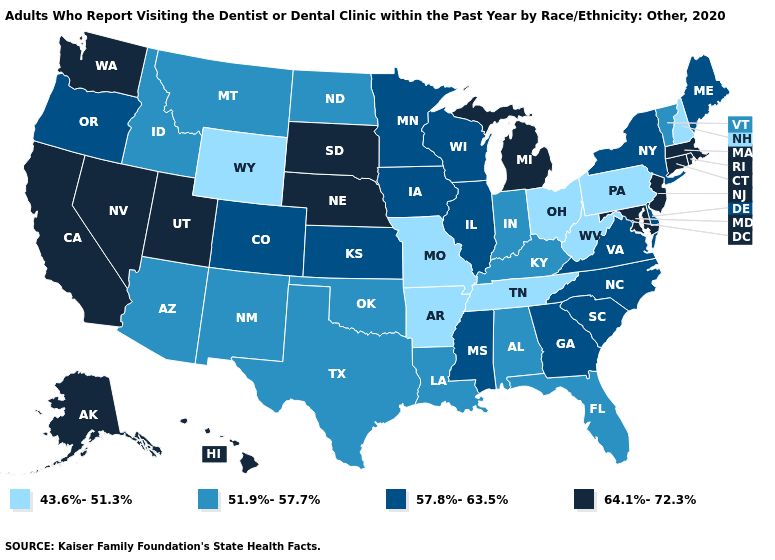Which states have the highest value in the USA?
Give a very brief answer. Alaska, California, Connecticut, Hawaii, Maryland, Massachusetts, Michigan, Nebraska, Nevada, New Jersey, Rhode Island, South Dakota, Utah, Washington. Name the states that have a value in the range 43.6%-51.3%?
Concise answer only. Arkansas, Missouri, New Hampshire, Ohio, Pennsylvania, Tennessee, West Virginia, Wyoming. Which states have the lowest value in the MidWest?
Short answer required. Missouri, Ohio. Among the states that border North Carolina , which have the highest value?
Keep it brief. Georgia, South Carolina, Virginia. Name the states that have a value in the range 64.1%-72.3%?
Give a very brief answer. Alaska, California, Connecticut, Hawaii, Maryland, Massachusetts, Michigan, Nebraska, Nevada, New Jersey, Rhode Island, South Dakota, Utah, Washington. How many symbols are there in the legend?
Answer briefly. 4. Is the legend a continuous bar?
Keep it brief. No. Among the states that border Mississippi , does Louisiana have the lowest value?
Be succinct. No. What is the highest value in the Northeast ?
Concise answer only. 64.1%-72.3%. What is the value of Texas?
Quick response, please. 51.9%-57.7%. What is the value of Colorado?
Give a very brief answer. 57.8%-63.5%. What is the lowest value in the South?
Give a very brief answer. 43.6%-51.3%. Among the states that border Maryland , does West Virginia have the highest value?
Concise answer only. No. Name the states that have a value in the range 51.9%-57.7%?
Write a very short answer. Alabama, Arizona, Florida, Idaho, Indiana, Kentucky, Louisiana, Montana, New Mexico, North Dakota, Oklahoma, Texas, Vermont. Among the states that border Kansas , does Nebraska have the lowest value?
Short answer required. No. 